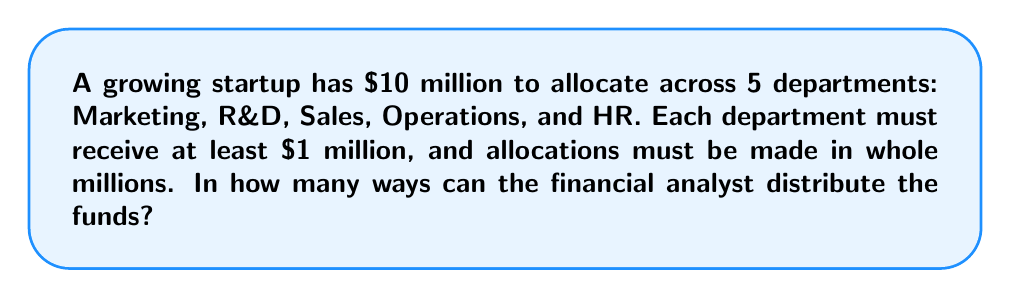Solve this math problem. Let's approach this step-by-step:

1) First, we need to recognize that this is a stars and bars problem in combinatorics.

2) We have $10 million to distribute, but each department must receive at least $1 million. So, we can start by giving each department $1 million, leaving us with $5 million to distribute freely.

3) Now, we have 5 departments (5 bars) and $5 million left to distribute (5 stars).

4) The formula for stars and bars is:

   $${n+k-1 \choose k-1}$$

   where n is the number of identical objects (stars) and k is the number of distinct boxes (bars).

5) In our case, n = 5 (remaining millions) and k = 5 (departments).

6) Plugging into the formula:

   $${5+5-1 \choose 5-1} = {9 \choose 4}$$

7) We can calculate this:

   $$\frac{9!}{4!(9-4)!} = \frac{9!}{4!5!} = \frac{9 \cdot 8 \cdot 7 \cdot 6}{4 \cdot 3 \cdot 2 \cdot 1} = 126$$

Therefore, there are 126 ways to distribute the funds.
Answer: 126 